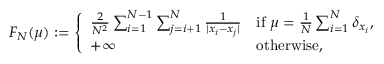<formula> <loc_0><loc_0><loc_500><loc_500>\begin{array} { r } { F _ { N } ( \mu ) \colon = \left \{ \begin{array} { l l } { { \frac { 2 } { N ^ { 2 } } } \sum _ { i = 1 } ^ { N - 1 } \sum _ { j = i + 1 } ^ { N } { \frac { 1 } { | x _ { i } - x _ { j } | } } } & { i f \ \mu = { \frac { 1 } { N } } \sum _ { i = 1 } ^ { N } \delta _ { x _ { i } } , } \\ { + \infty } & { o t h e r w i s e , } \end{array} } \end{array}</formula> 